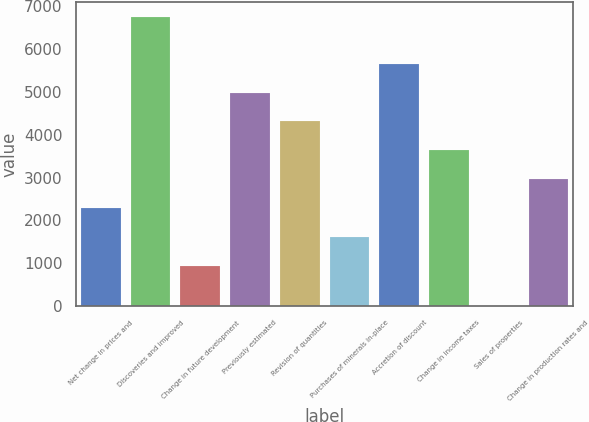Convert chart to OTSL. <chart><loc_0><loc_0><loc_500><loc_500><bar_chart><fcel>Net change in prices and<fcel>Discoveries and improved<fcel>Change in future development<fcel>Previously estimated<fcel>Revision of quantities<fcel>Purchases of minerals in-place<fcel>Accretion of discount<fcel>Change in income taxes<fcel>Sales of properties<fcel>Change in production rates and<nl><fcel>2282.8<fcel>6742<fcel>935<fcel>4978.4<fcel>4304.5<fcel>1608.9<fcel>5652.3<fcel>3630.6<fcel>3<fcel>2956.7<nl></chart> 